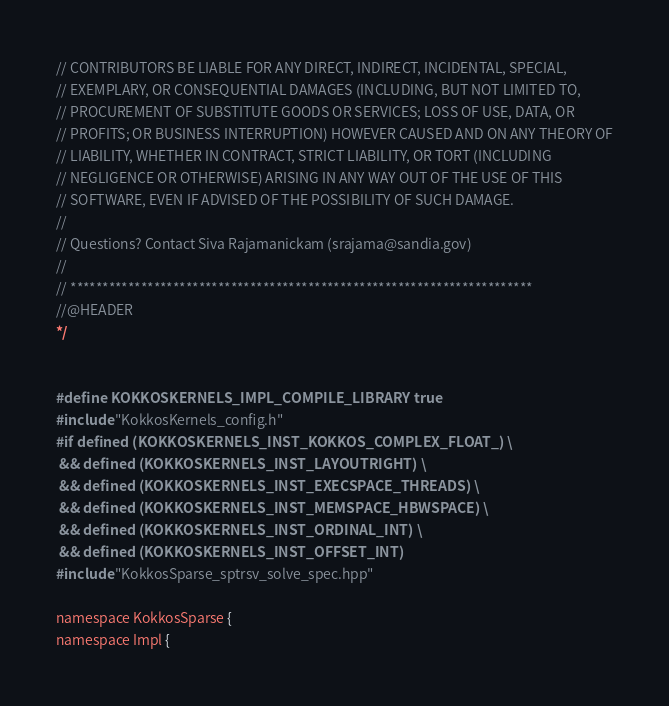Convert code to text. <code><loc_0><loc_0><loc_500><loc_500><_C++_>// CONTRIBUTORS BE LIABLE FOR ANY DIRECT, INDIRECT, INCIDENTAL, SPECIAL,
// EXEMPLARY, OR CONSEQUENTIAL DAMAGES (INCLUDING, BUT NOT LIMITED TO,
// PROCUREMENT OF SUBSTITUTE GOODS OR SERVICES; LOSS OF USE, DATA, OR
// PROFITS; OR BUSINESS INTERRUPTION) HOWEVER CAUSED AND ON ANY THEORY OF
// LIABILITY, WHETHER IN CONTRACT, STRICT LIABILITY, OR TORT (INCLUDING
// NEGLIGENCE OR OTHERWISE) ARISING IN ANY WAY OUT OF THE USE OF THIS
// SOFTWARE, EVEN IF ADVISED OF THE POSSIBILITY OF SUCH DAMAGE.
//
// Questions? Contact Siva Rajamanickam (srajama@sandia.gov)
//
// ************************************************************************
//@HEADER
*/


#define KOKKOSKERNELS_IMPL_COMPILE_LIBRARY true
#include "KokkosKernels_config.h"
#if defined (KOKKOSKERNELS_INST_KOKKOS_COMPLEX_FLOAT_) \
 && defined (KOKKOSKERNELS_INST_LAYOUTRIGHT) \
 && defined (KOKKOSKERNELS_INST_EXECSPACE_THREADS) \
 && defined (KOKKOSKERNELS_INST_MEMSPACE_HBWSPACE) \
 && defined (KOKKOSKERNELS_INST_ORDINAL_INT) \
 && defined (KOKKOSKERNELS_INST_OFFSET_INT) 
#include "KokkosSparse_sptrsv_solve_spec.hpp"

namespace KokkosSparse {
namespace Impl {</code> 